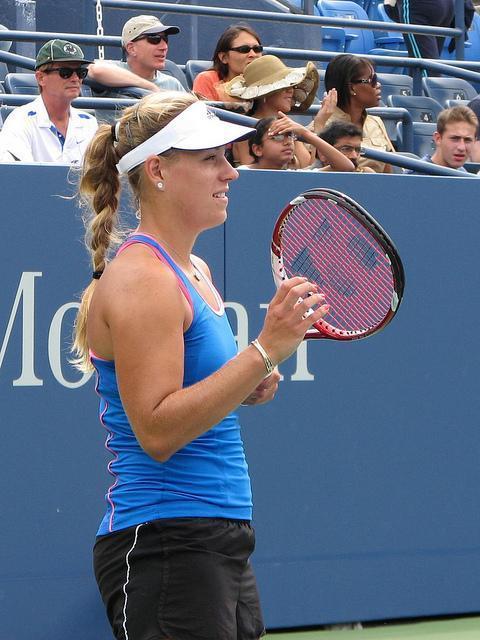How many people are in the photo?
Give a very brief answer. 8. 